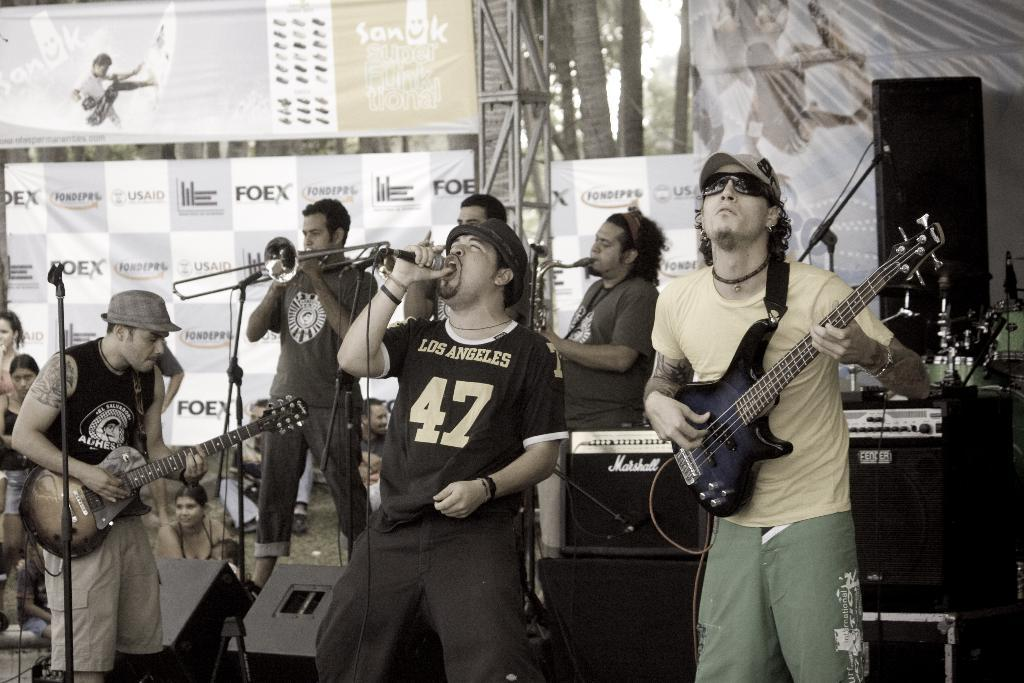What is happening in the image? There is a group of musicians in the image, and they are playing musical instruments. What can be seen in the background of the image? There are hoardings and metal rods in the background of the image. Are there any musical instruments visible in the background? Yes, there are musical instruments in the background of the image. What type of sweater is the musician wearing in the image? There is no sweater mentioned or visible in the image. The musicians are not wearing any clothing that is described or depicted. 